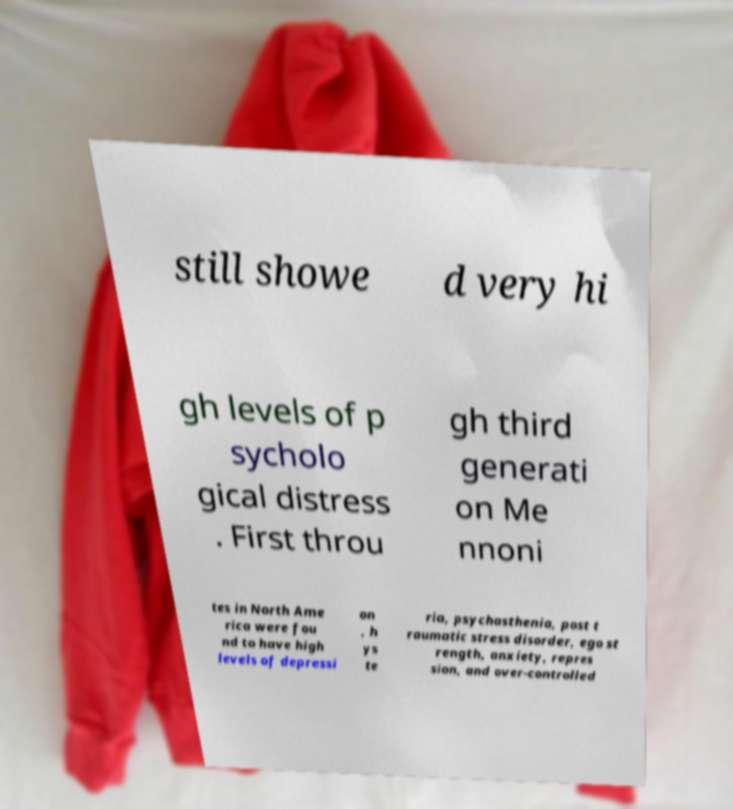Can you read and provide the text displayed in the image?This photo seems to have some interesting text. Can you extract and type it out for me? still showe d very hi gh levels of p sycholo gical distress . First throu gh third generati on Me nnoni tes in North Ame rica were fou nd to have high levels of depressi on , h ys te ria, psychasthenia, post t raumatic stress disorder, ego st rength, anxiety, repres sion, and over-controlled 